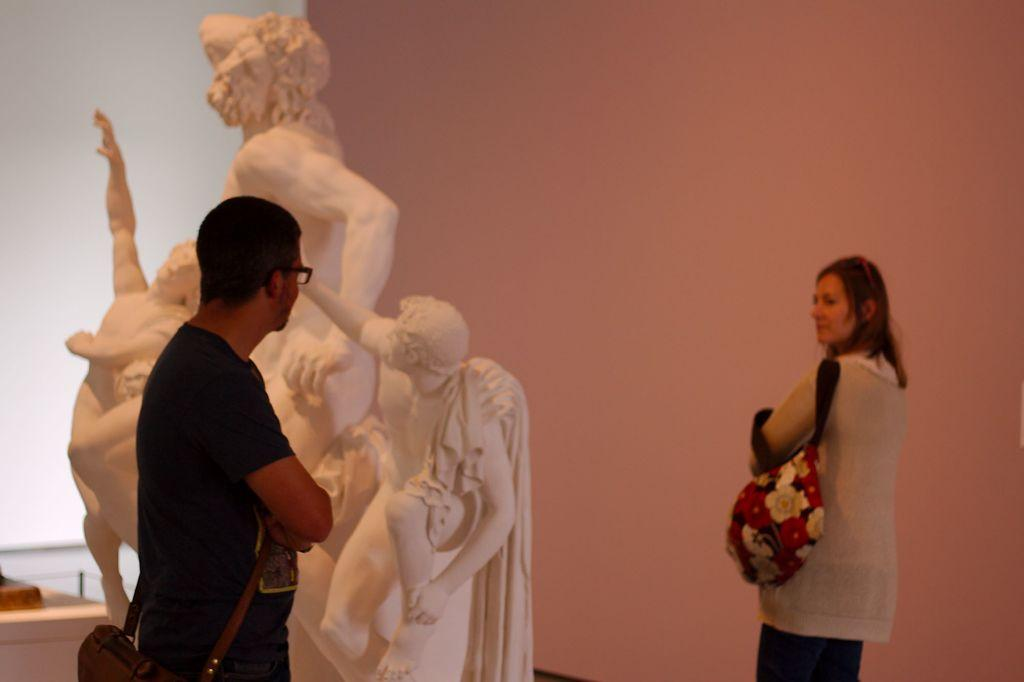How many people are in the image? There are two persons standing in the image. What is the surface on which the persons are standing? The persons are standing on the floor. What can be seen behind the persons in the image? There is a statue behind the persons. What is the background of the image made up of? There is a wall visible in the image. What type of house can be seen in the image? There is no house present in the image. What sense is being stimulated by the statue in the image? The image does not provide information about the statue stimulating any sense. 